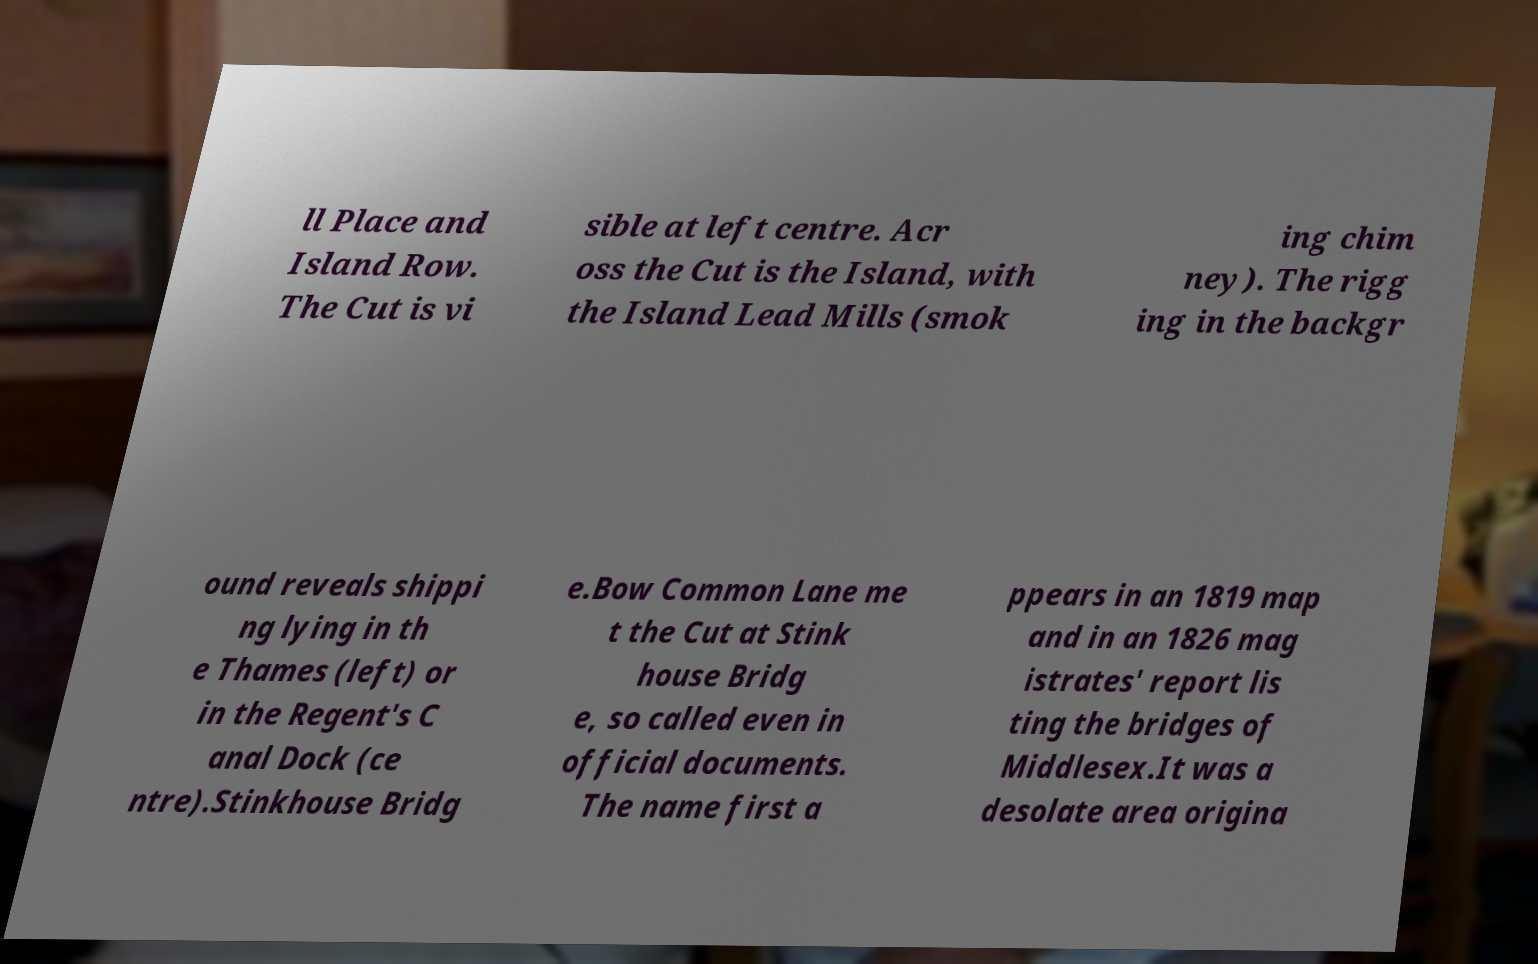I need the written content from this picture converted into text. Can you do that? ll Place and Island Row. The Cut is vi sible at left centre. Acr oss the Cut is the Island, with the Island Lead Mills (smok ing chim ney). The rigg ing in the backgr ound reveals shippi ng lying in th e Thames (left) or in the Regent's C anal Dock (ce ntre).Stinkhouse Bridg e.Bow Common Lane me t the Cut at Stink house Bridg e, so called even in official documents. The name first a ppears in an 1819 map and in an 1826 mag istrates' report lis ting the bridges of Middlesex.It was a desolate area origina 